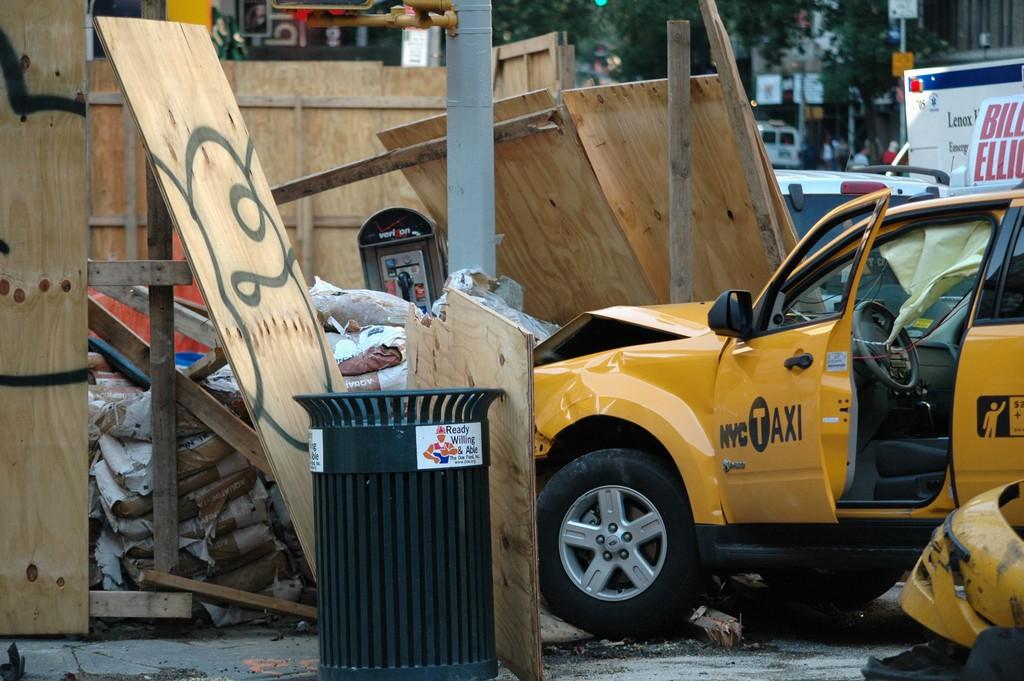What sort of vehicle is it?
Give a very brief answer. Taxi. 